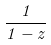<formula> <loc_0><loc_0><loc_500><loc_500>\frac { 1 } { 1 - z }</formula> 